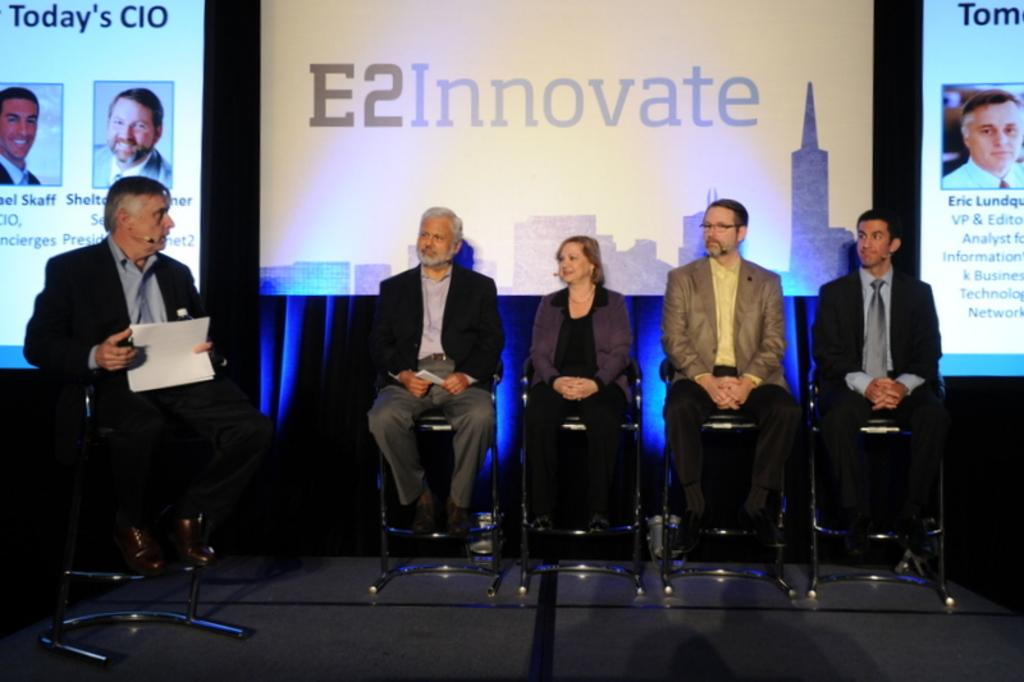What are the people in the image doing? The people in the image are sitting on chairs. What can be seen in the background of the image? There are screens in the background of the image. What is visible at the bottom of the image? There is a floor visible at the bottom of the image. What type of wave can be seen crashing on the shore in the image? There is no wave or shore present in the image; it features people sitting on chairs with screens in the background. 